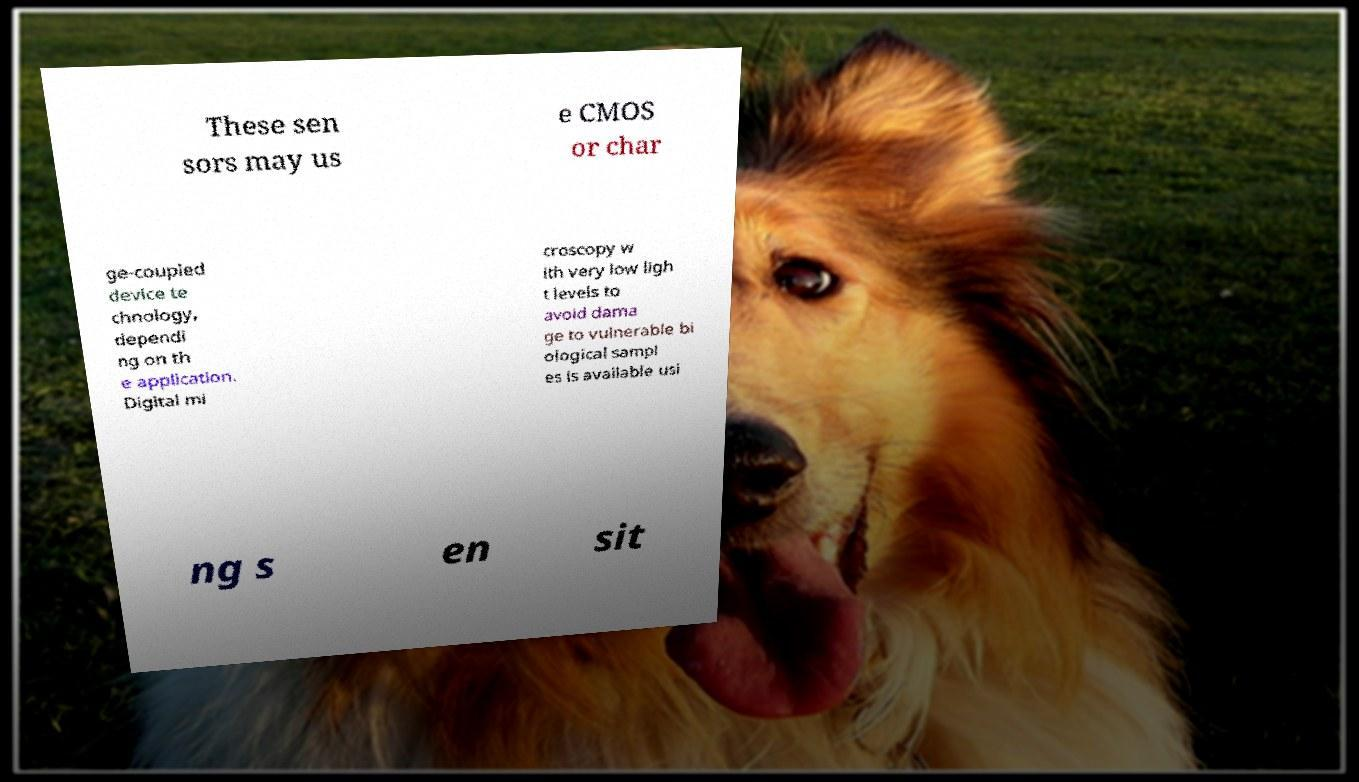Please read and relay the text visible in this image. What does it say? These sen sors may us e CMOS or char ge-coupled device te chnology, dependi ng on th e application. Digital mi croscopy w ith very low ligh t levels to avoid dama ge to vulnerable bi ological sampl es is available usi ng s en sit 